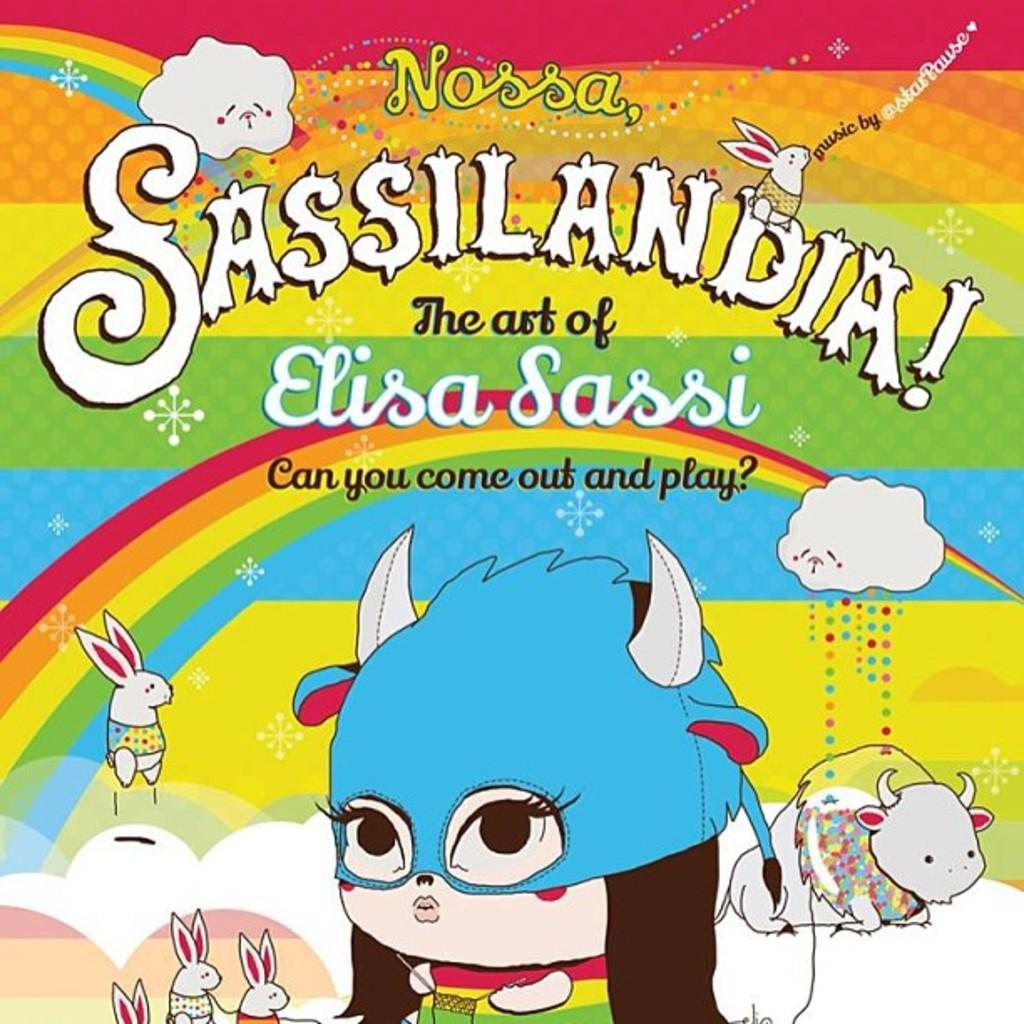What type of poster is in the image? There is a colorful poster in the image. What can be seen at the bottom of the poster? The poster has cartoon characters depicted at the bottom. Where is the text located on the poster? There is text visible at the top of the image. How many squirrels are climbing on the cartoon characters in the image? There are no squirrels present in the image; the poster features cartoon characters without any squirrels. What type of event is being advertised on the poster? The image does not provide enough information to determine if the poster is advertising an event or not. 